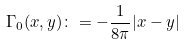Convert formula to latex. <formula><loc_0><loc_0><loc_500><loc_500>\Gamma _ { 0 } ( x , y ) \colon = - \frac { 1 } { 8 \pi } | x - y |</formula> 